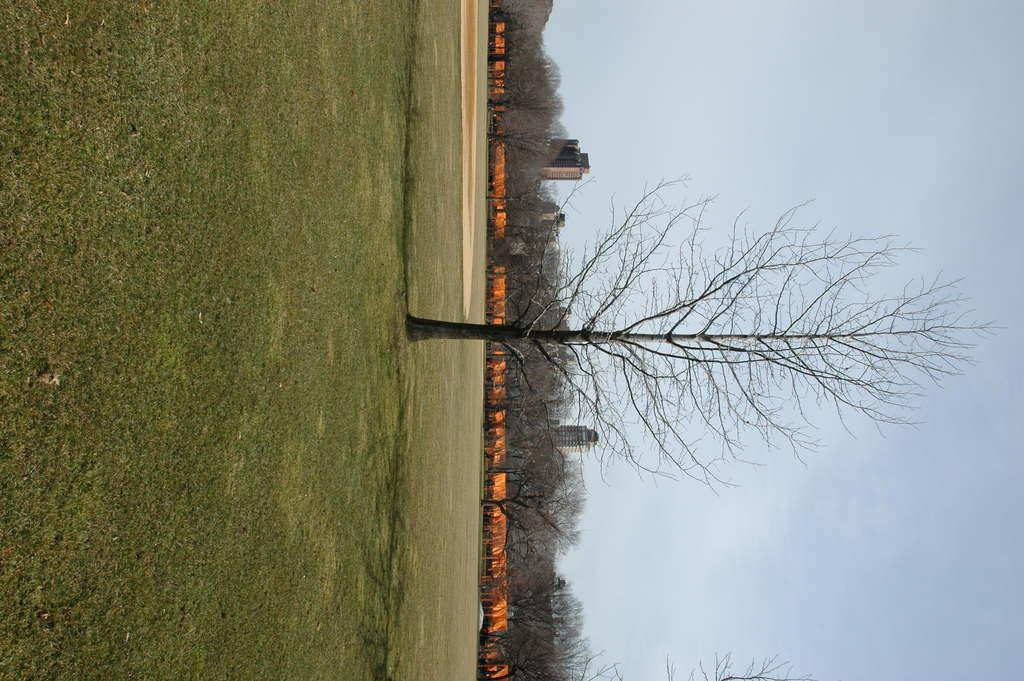What type of surface is visible in the image? There is ground visible in the image. What type of vegetation is present on the ground? There is grass on the ground. What other natural elements can be seen in the image? There is a tree in the image. What can be seen in the background of the image? There are orange colored objects, trees, buildings, and the sky visible in the background. What type of marble is being used by the team in the image? There is no marble or team present in the image. What is causing the people in the image to laugh? There are no people or laughter present in the image. 